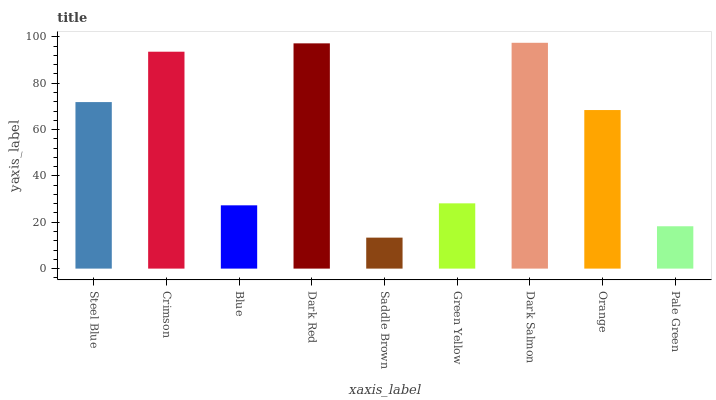Is Saddle Brown the minimum?
Answer yes or no. Yes. Is Dark Salmon the maximum?
Answer yes or no. Yes. Is Crimson the minimum?
Answer yes or no. No. Is Crimson the maximum?
Answer yes or no. No. Is Crimson greater than Steel Blue?
Answer yes or no. Yes. Is Steel Blue less than Crimson?
Answer yes or no. Yes. Is Steel Blue greater than Crimson?
Answer yes or no. No. Is Crimson less than Steel Blue?
Answer yes or no. No. Is Orange the high median?
Answer yes or no. Yes. Is Orange the low median?
Answer yes or no. Yes. Is Dark Salmon the high median?
Answer yes or no. No. Is Crimson the low median?
Answer yes or no. No. 